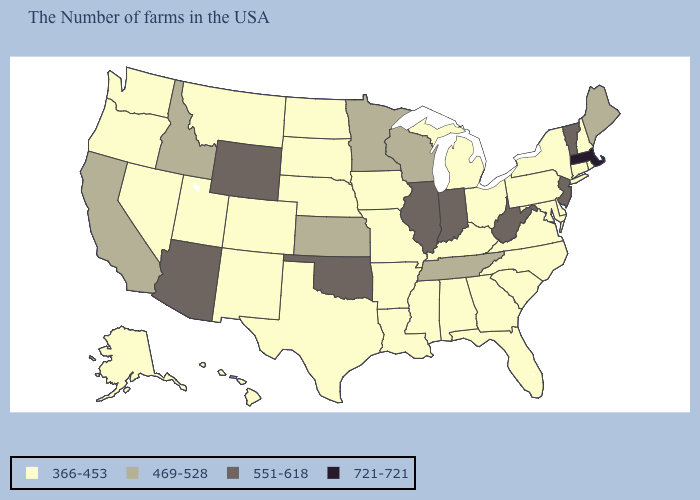Which states have the highest value in the USA?
Quick response, please. Massachusetts. What is the value of Virginia?
Quick response, please. 366-453. Name the states that have a value in the range 721-721?
Keep it brief. Massachusetts. What is the value of Georgia?
Answer briefly. 366-453. What is the value of North Dakota?
Be succinct. 366-453. Name the states that have a value in the range 469-528?
Answer briefly. Maine, Tennessee, Wisconsin, Minnesota, Kansas, Idaho, California. What is the value of Georgia?
Write a very short answer. 366-453. Does Rhode Island have the lowest value in the USA?
Concise answer only. Yes. Does Indiana have the highest value in the MidWest?
Write a very short answer. Yes. Does California have a higher value than Florida?
Short answer required. Yes. What is the value of Maine?
Concise answer only. 469-528. Does Minnesota have the highest value in the MidWest?
Answer briefly. No. What is the value of Arizona?
Quick response, please. 551-618. What is the value of Wyoming?
Concise answer only. 551-618. 